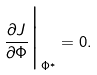Convert formula to latex. <formula><loc_0><loc_0><loc_500><loc_500>\frac { \partial J } { \partial \Phi } { \Big | } _ { \Phi ^ { * } } = 0 .</formula> 